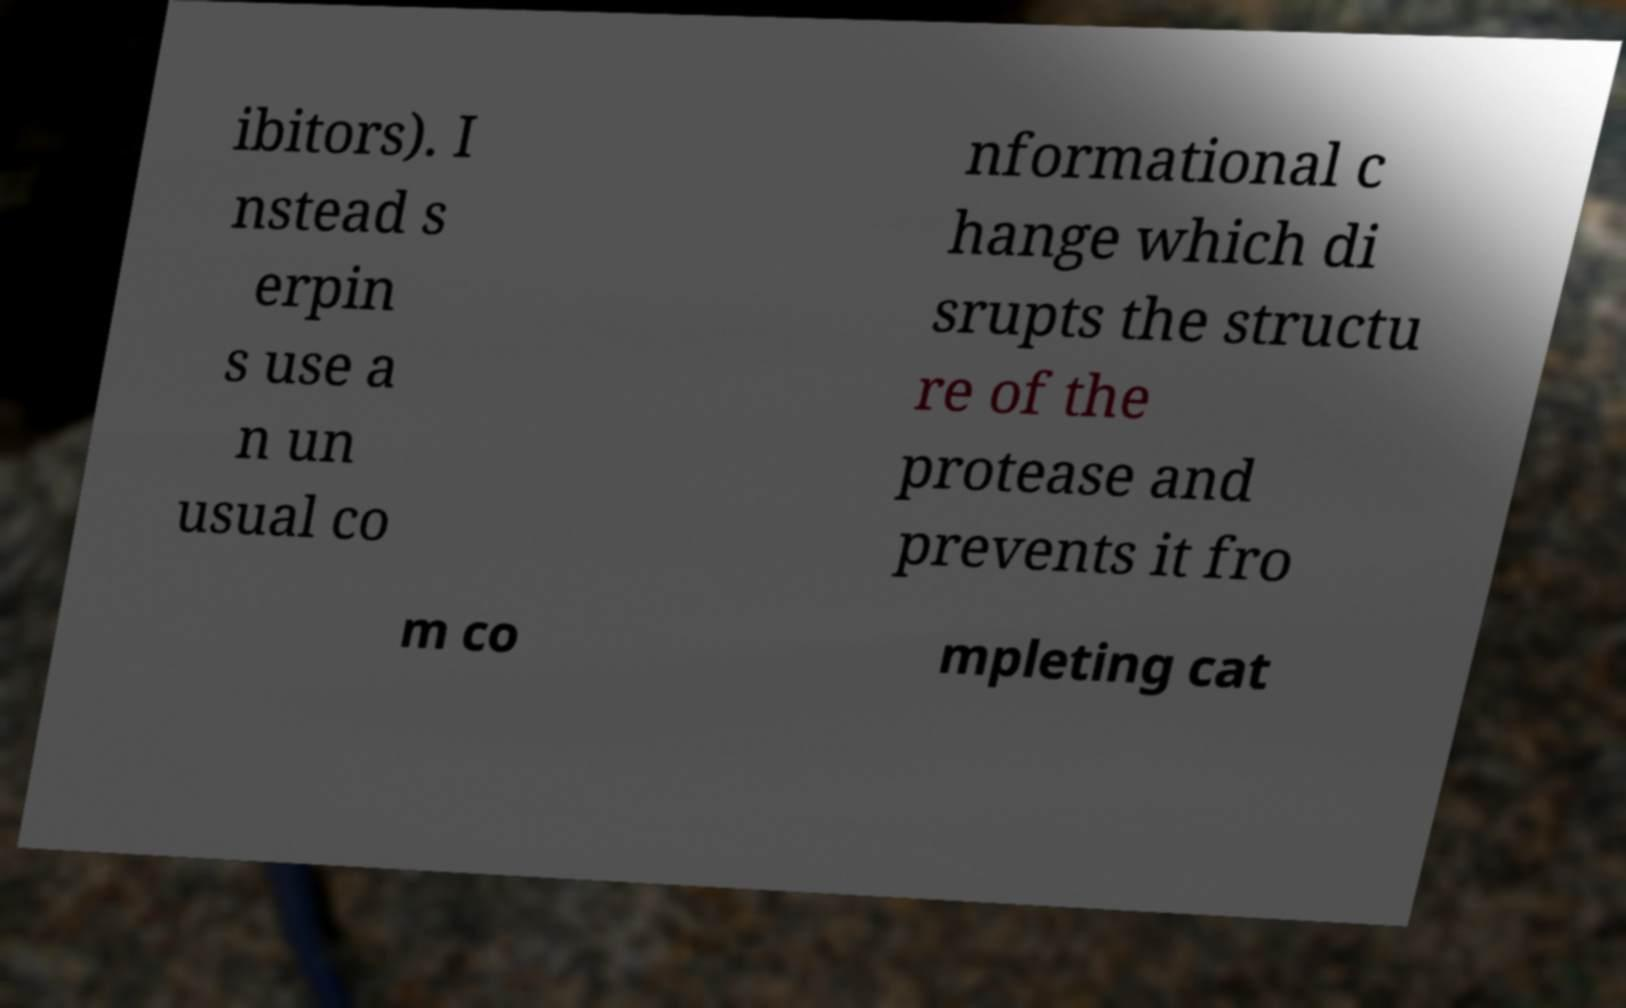Can you read and provide the text displayed in the image?This photo seems to have some interesting text. Can you extract and type it out for me? ibitors). I nstead s erpin s use a n un usual co nformational c hange which di srupts the structu re of the protease and prevents it fro m co mpleting cat 